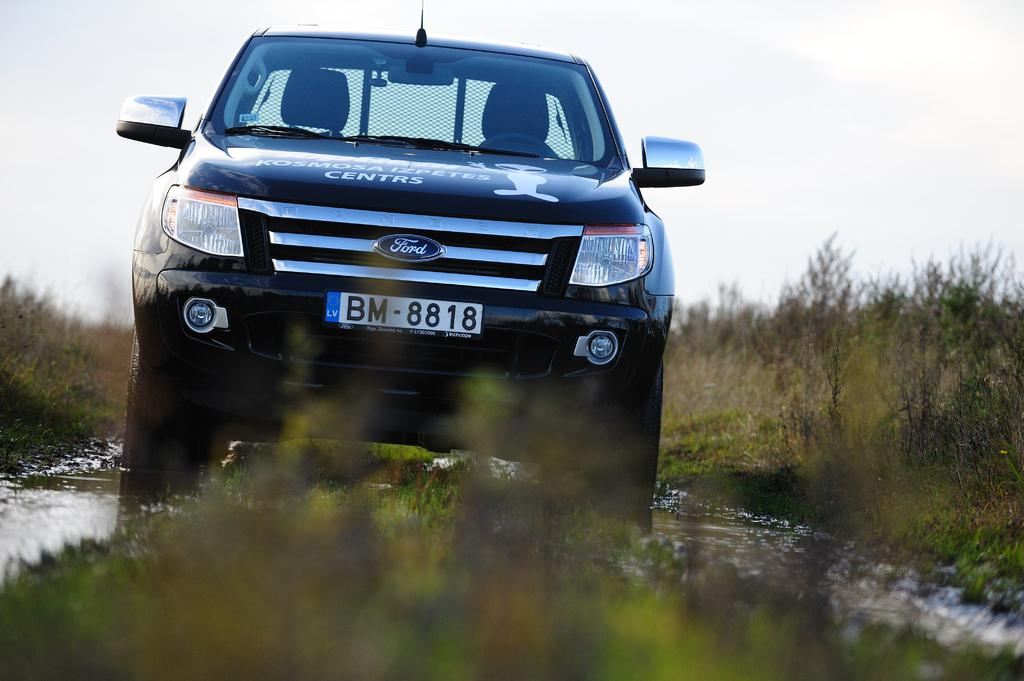What is the main subject of the image? There is a car in the image. Where is the car located? The car is on water. What type of vegetation can be seen in the image? There is grass visible in the image, and there are also trees. What can be seen in the background of the image? The sky is visible in the background of the image. What time does the clock in the image show? There is no clock present in the image. Can you describe the movement of the snail in the image? There is no snail present in the image. 